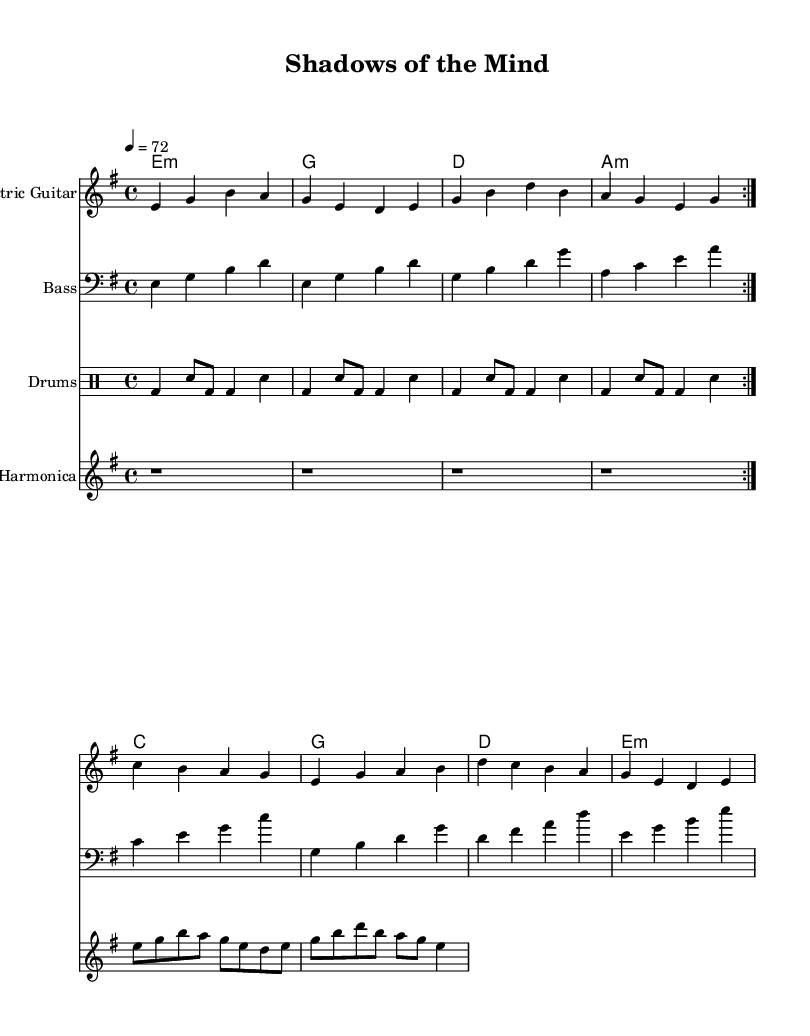What is the key signature of this music? The key signature is E minor, which has one sharp (F#). This can be determined by looking at the key signature notation at the beginning of the score.
Answer: E minor What is the time signature of the piece? The time signature is 4/4, as indicated at the beginning of the score. This means there are four beats in each measure, and the quarter note gets one beat.
Answer: 4/4 What is the tempo marking provided in the music? The tempo marking is 4 = 72, which means there are 72 beats per minute (BPM). This is found in the tempo directive at the beginning of the score.
Answer: 72 How many times is the electric guitar part repeated? The electric guitar part is repeated twice, as indicated by the notation 'volta 2' after the repeating section.
Answer: twice What is the primary chord used in the first measure? The primary chord used in the first measure is E minor, as indicated by the chord symbols above the staff. The chord is defined by the notes E, G, and B played together.
Answer: E minor Which instruments are included in this score? The instruments included are Electric Guitar, Bass, Drums, and Harmonica. This can be seen from the staff labels at the beginning of each musical part.
Answer: Electric Guitar, Bass, Drums, Harmonica What unique element in this Electric Blues piece reflects its emotional depth? The harmonica part, which introduces a raw and plaintive quality, adds emotional depth reflecting the psychological complexity. The use of expressive notes in the harmonica illustrates this poignancy.
Answer: Harmonica 